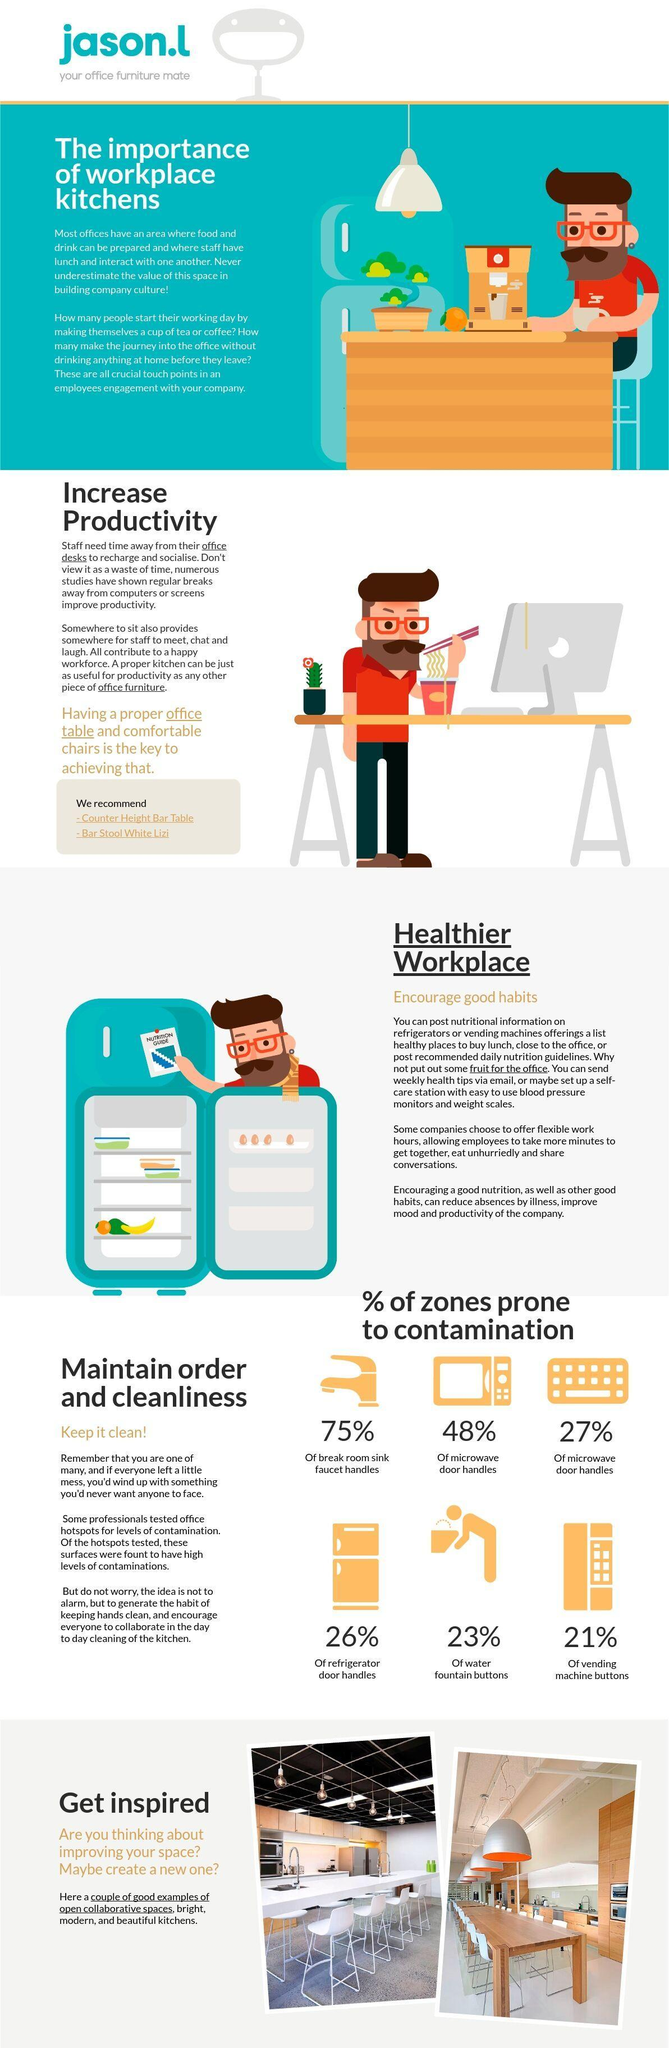What percentage of vending machine buttons is prone to contamination?
Answer the question with a short phrase. 21% How many eggs are there in the refrigerator? 4 What is the colour of the chair in the second last image - orange, white or blue? White What percentage of breakroom sink faucet handles is prone to contamination? 75% How many bulbs are hanging from the ceiling in the second last image? 6 What is written on the post placed on the refrigerator? Nutrition guide How many contamination prone zones are shown here? 6 